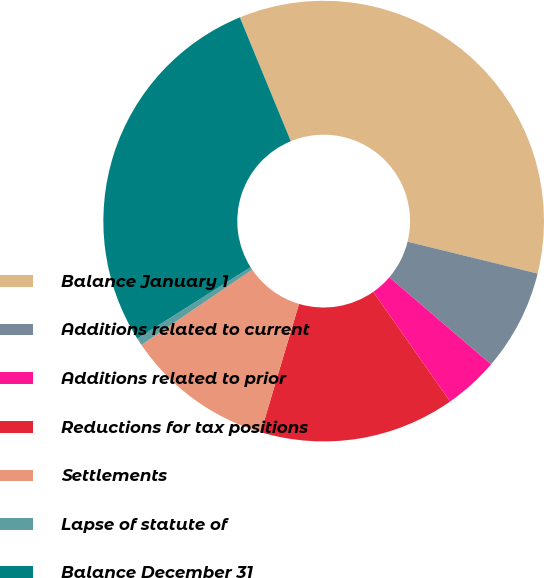Convert chart. <chart><loc_0><loc_0><loc_500><loc_500><pie_chart><fcel>Balance January 1<fcel>Additions related to current<fcel>Additions related to prior<fcel>Reductions for tax positions<fcel>Settlements<fcel>Lapse of statute of<fcel>Balance December 31<nl><fcel>35.04%<fcel>7.44%<fcel>4.0%<fcel>14.34%<fcel>10.89%<fcel>0.55%<fcel>27.74%<nl></chart> 